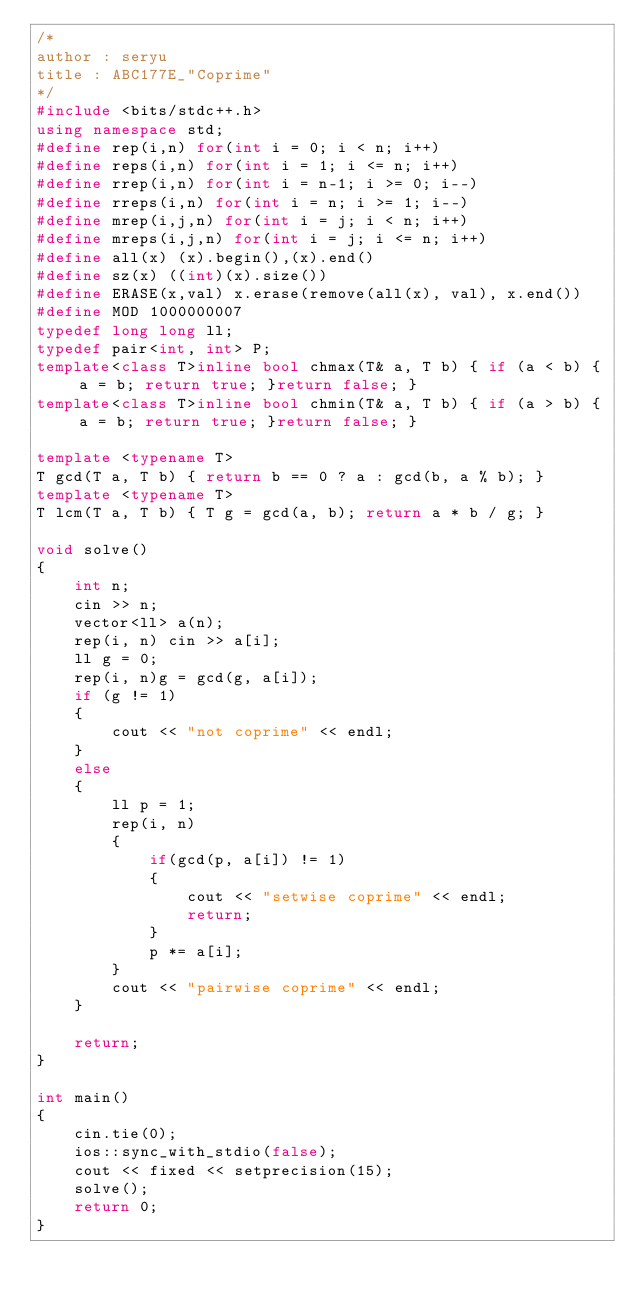<code> <loc_0><loc_0><loc_500><loc_500><_C++_>/*
author : seryu
title : ABC177E_"Coprime"
*/
#include <bits/stdc++.h>
using namespace std;
#define rep(i,n) for(int i = 0; i < n; i++)
#define reps(i,n) for(int i = 1; i <= n; i++)
#define rrep(i,n) for(int i = n-1; i >= 0; i--)
#define rreps(i,n) for(int i = n; i >= 1; i--)
#define mrep(i,j,n) for(int i = j; i < n; i++)
#define mreps(i,j,n) for(int i = j; i <= n; i++)
#define all(x) (x).begin(),(x).end()
#define sz(x) ((int)(x).size())
#define ERASE(x,val) x.erase(remove(all(x), val), x.end())
#define MOD 1000000007
typedef long long ll;
typedef pair<int, int> P;
template<class T>inline bool chmax(T& a, T b) { if (a < b) { a = b; return true; }return false; }
template<class T>inline bool chmin(T& a, T b) { if (a > b) { a = b; return true; }return false; }

template <typename T>
T gcd(T a, T b) { return b == 0 ? a : gcd(b, a % b); }
template <typename T>
T lcm(T a, T b) { T g = gcd(a, b); return a * b / g; }

void solve()
{
    int n;
    cin >> n;
    vector<ll> a(n);
    rep(i, n) cin >> a[i];
    ll g = 0;
    rep(i, n)g = gcd(g, a[i]);
    if (g != 1)
    {
        cout << "not coprime" << endl;
    }
    else
    {
        ll p = 1;
        rep(i, n)
        {
            if(gcd(p, a[i]) != 1)
            {
                cout << "setwise coprime" << endl;
                return;
            }
            p *= a[i];
        }
        cout << "pairwise coprime" << endl;
    }

    return;	
}

int main()
{
    cin.tie(0);
    ios::sync_with_stdio(false);
    cout << fixed << setprecision(15);
    solve();
    return 0;
}
</code> 